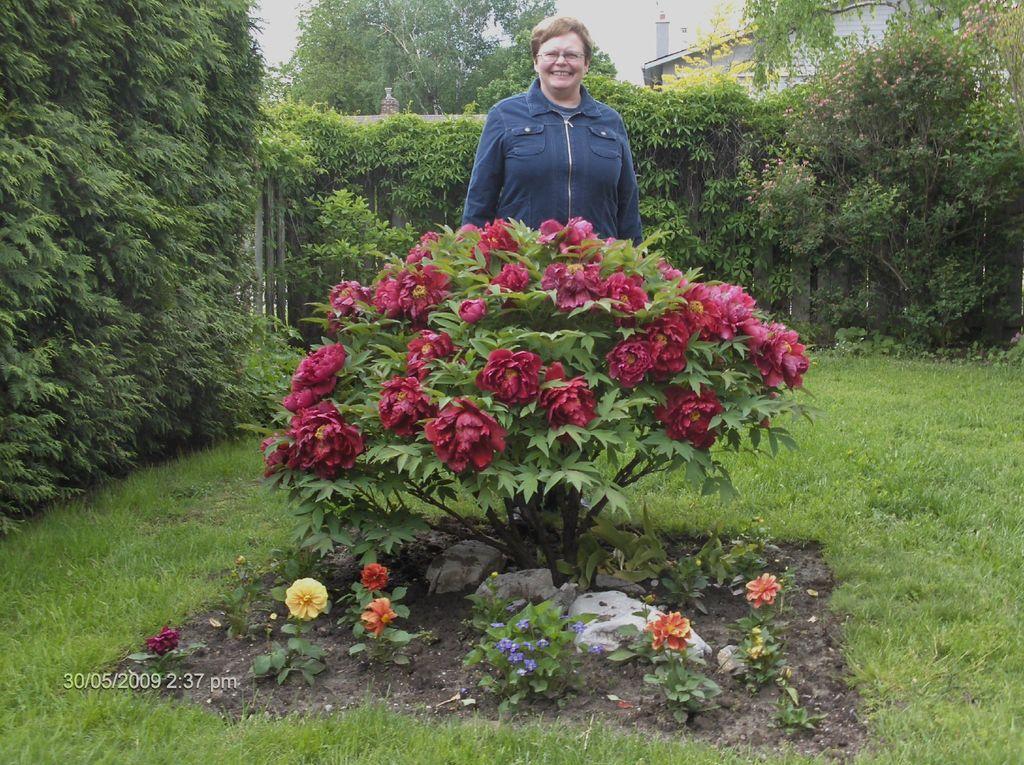Describe this image in one or two sentences. In this image I can see grass, few flowers, trees and a building. I can also see a woman is standing and I can see she is wearing blue dress. I can also see a smile on her face. I can see colour of these flowers are red, yellow and orange. 